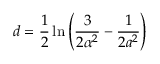Convert formula to latex. <formula><loc_0><loc_0><loc_500><loc_500>d = \frac { 1 } { 2 } \ln { \left ( \frac { 3 } { 2 \alpha ^ { 2 } } - \frac { 1 } { 2 a ^ { 2 } } \right ) }</formula> 